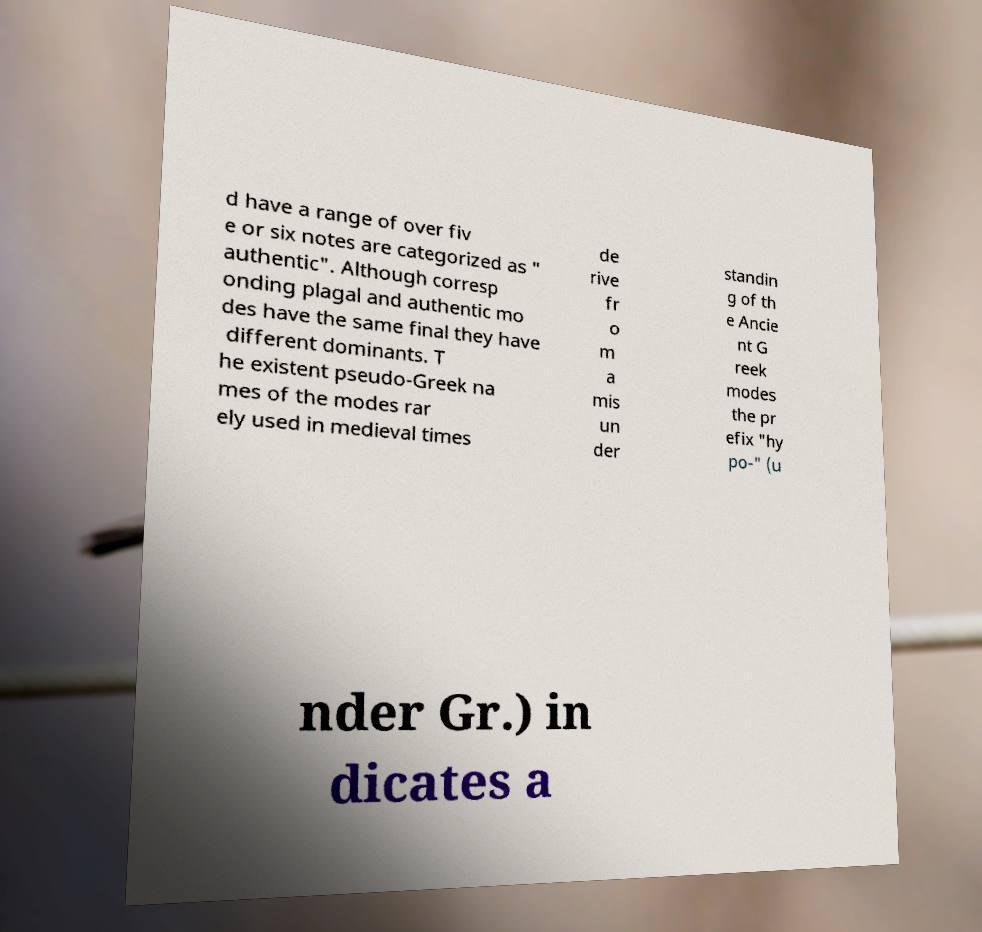Can you read and provide the text displayed in the image?This photo seems to have some interesting text. Can you extract and type it out for me? d have a range of over fiv e or six notes are categorized as " authentic". Although corresp onding plagal and authentic mo des have the same final they have different dominants. T he existent pseudo-Greek na mes of the modes rar ely used in medieval times de rive fr o m a mis un der standin g of th e Ancie nt G reek modes the pr efix "hy po-" (u nder Gr.) in dicates a 